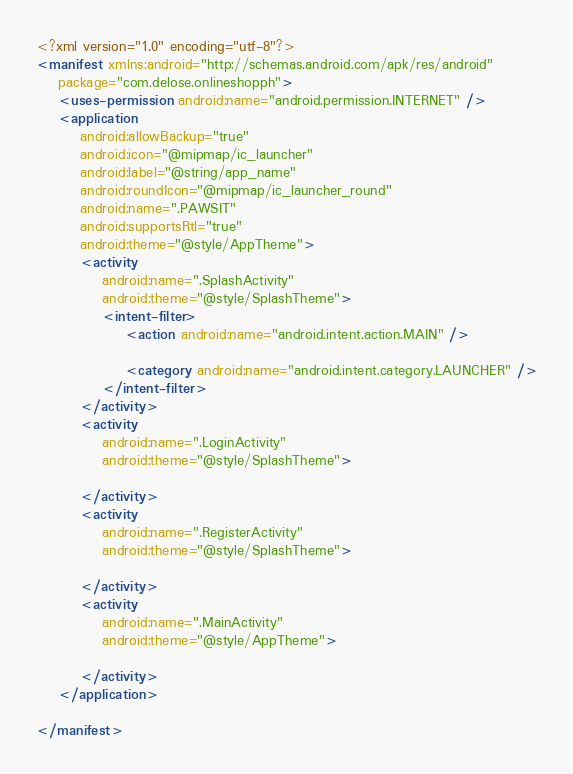<code> <loc_0><loc_0><loc_500><loc_500><_XML_><?xml version="1.0" encoding="utf-8"?>
<manifest xmlns:android="http://schemas.android.com/apk/res/android"
    package="com.delose.onlineshopph">
    <uses-permission android:name="android.permission.INTERNET" />
    <application
        android:allowBackup="true"
        android:icon="@mipmap/ic_launcher"
        android:label="@string/app_name"
        android:roundIcon="@mipmap/ic_launcher_round"
        android:name=".PAWSIT"
        android:supportsRtl="true"
        android:theme="@style/AppTheme">
        <activity
            android:name=".SplashActivity"
            android:theme="@style/SplashTheme">
            <intent-filter>
                <action android:name="android.intent.action.MAIN" />

                <category android:name="android.intent.category.LAUNCHER" />
            </intent-filter>
        </activity>
        <activity
            android:name=".LoginActivity"
            android:theme="@style/SplashTheme">

        </activity>
        <activity
            android:name=".RegisterActivity"
            android:theme="@style/SplashTheme">

        </activity>
        <activity
            android:name=".MainActivity"
            android:theme="@style/AppTheme">

        </activity>
    </application>

</manifest></code> 